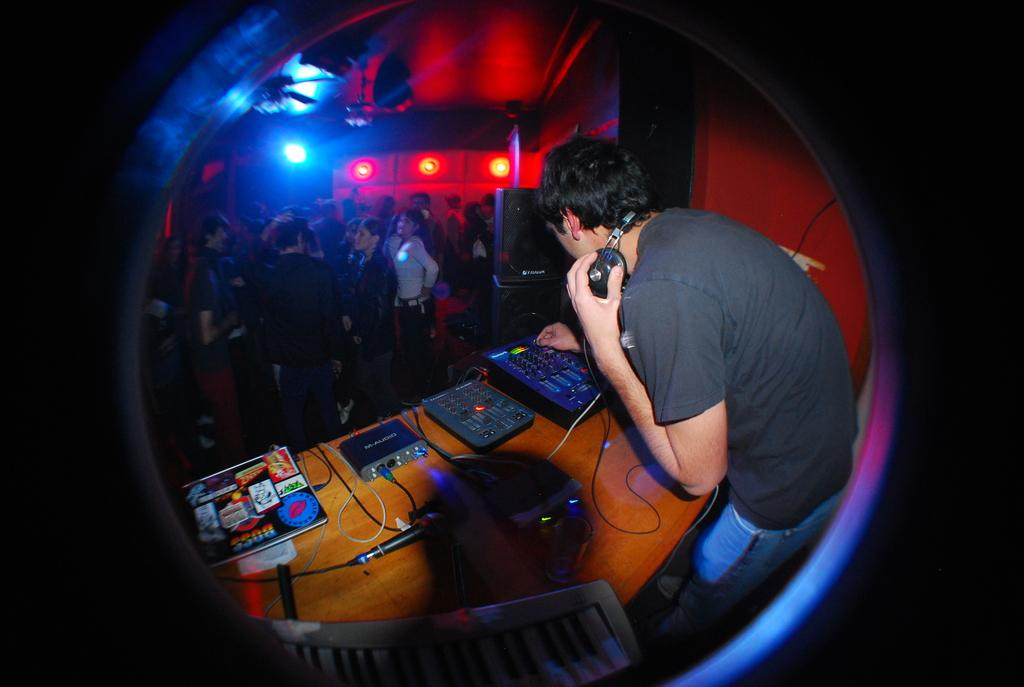What is the person in the image wearing? The person in the image is wearing a headset. What is the main piece of furniture in the image? There is a table in the image. What items can be seen on the table? Devices, cables, a microphone, and speakers are present on the table. What type of seating is available in the image? There is a chair in the image. How many people are in the image? There are people in the image. What can be seen in the image that provides illumination? Lights are visible in the image. How many mice are running around on the table in the image? There are no mice present on the table in the image. What type of machine is being used by the person in the image? The image does not show any specific machine being used by the person; it only shows a person wearing a headset and various devices on the table. 